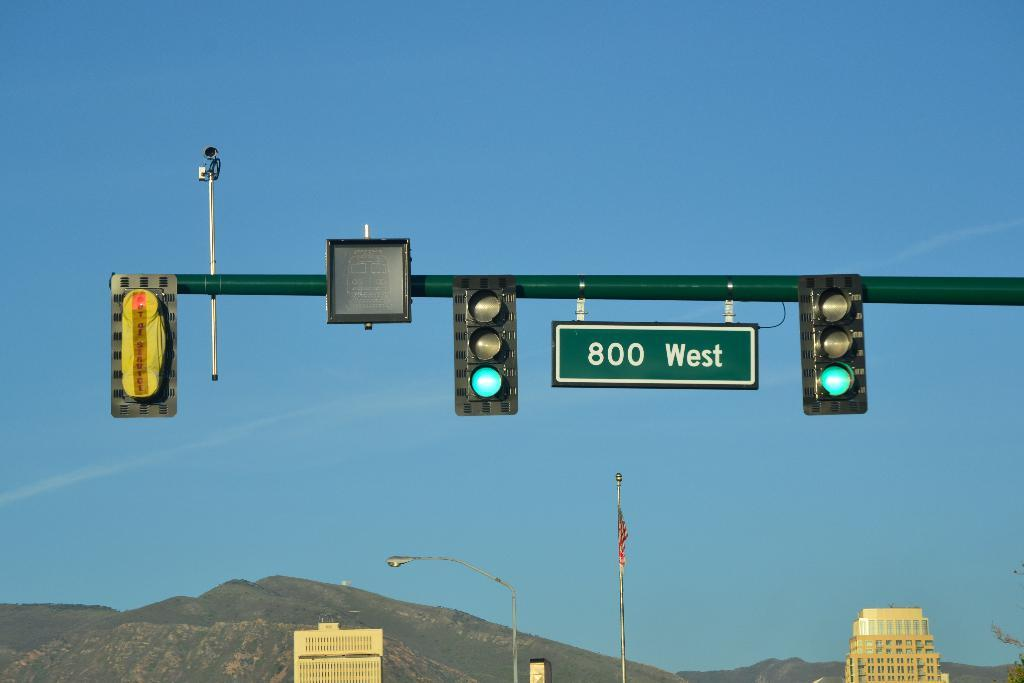<image>
Describe the image concisely. With mountains in the background, green lights are present at 800 West street. 